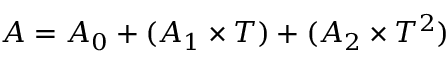<formula> <loc_0><loc_0><loc_500><loc_500>A = A _ { 0 } + ( A _ { 1 } \times T ) + ( A _ { 2 } \times T ^ { 2 } )</formula> 